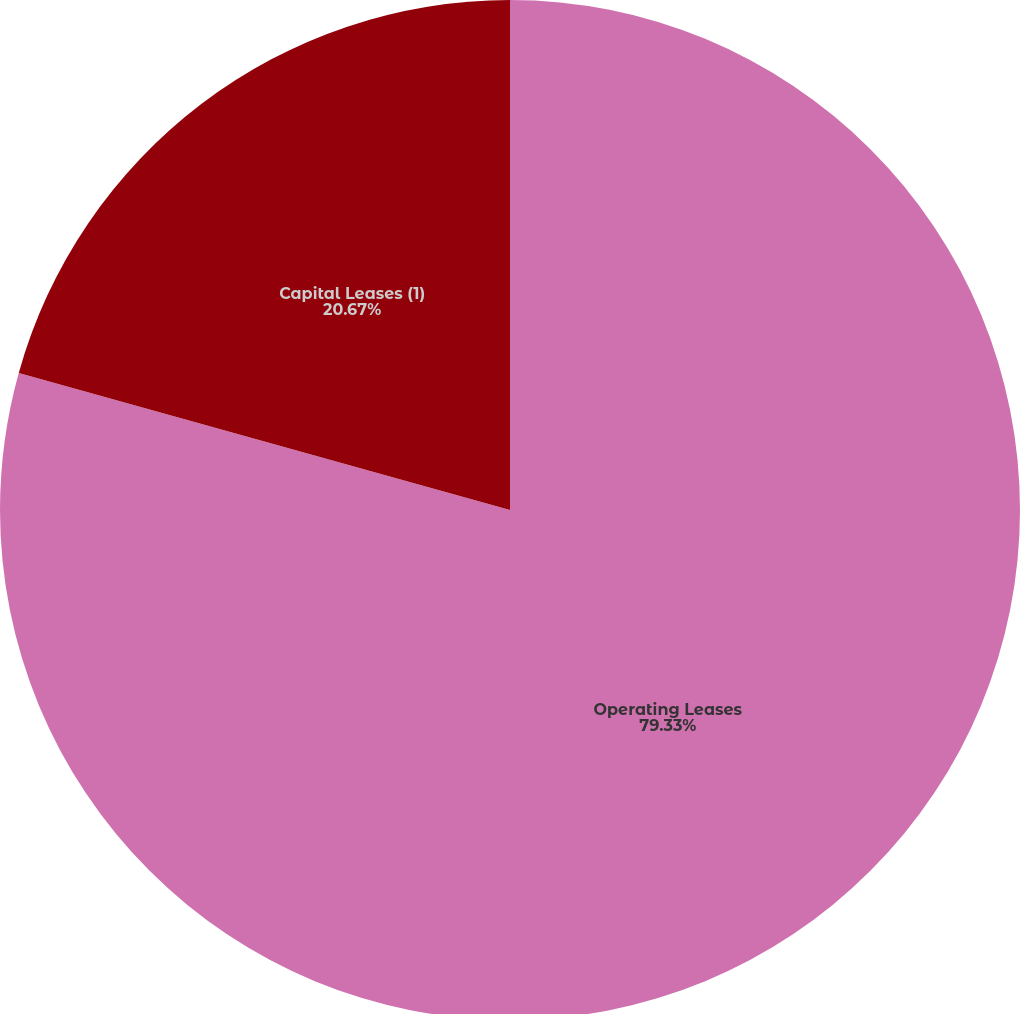Convert chart to OTSL. <chart><loc_0><loc_0><loc_500><loc_500><pie_chart><fcel>Operating Leases<fcel>Capital Leases (1)<nl><fcel>79.33%<fcel>20.67%<nl></chart> 